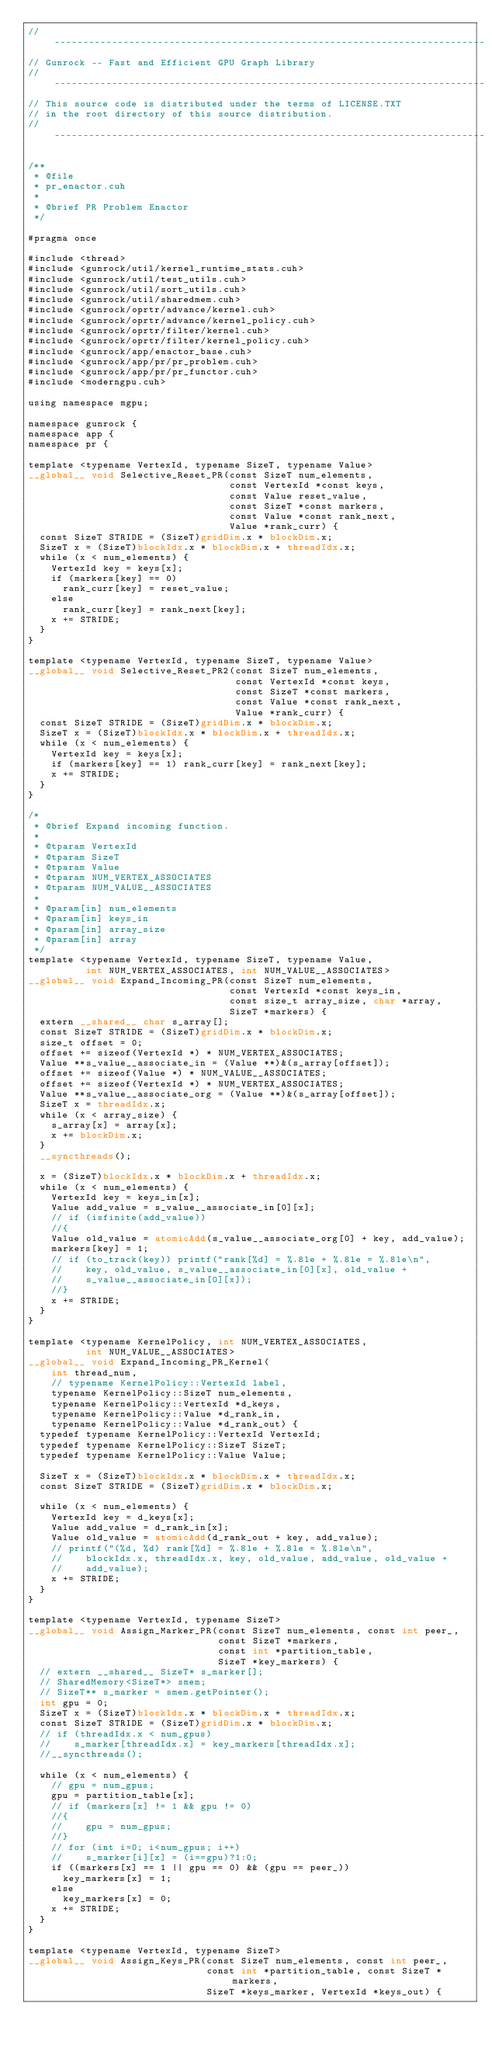<code> <loc_0><loc_0><loc_500><loc_500><_Cuda_>// ---------------------------------------------------------------------------
// Gunrock -- Fast and Efficient GPU Graph Library
// ---------------------------------------------------------------------------
// This source code is distributed under the terms of LICENSE.TXT
// in the root directory of this source distribution.
// ---------------------------------------------------------------------------

/**
 * @file
 * pr_enactor.cuh
 *
 * @brief PR Problem Enactor
 */

#pragma once

#include <thread>
#include <gunrock/util/kernel_runtime_stats.cuh>
#include <gunrock/util/test_utils.cuh>
#include <gunrock/util/sort_utils.cuh>
#include <gunrock/util/sharedmem.cuh>
#include <gunrock/oprtr/advance/kernel.cuh>
#include <gunrock/oprtr/advance/kernel_policy.cuh>
#include <gunrock/oprtr/filter/kernel.cuh>
#include <gunrock/oprtr/filter/kernel_policy.cuh>
#include <gunrock/app/enactor_base.cuh>
#include <gunrock/app/pr/pr_problem.cuh>
#include <gunrock/app/pr/pr_functor.cuh>
#include <moderngpu.cuh>

using namespace mgpu;

namespace gunrock {
namespace app {
namespace pr {

template <typename VertexId, typename SizeT, typename Value>
__global__ void Selective_Reset_PR(const SizeT num_elements,
                                   const VertexId *const keys,
                                   const Value reset_value,
                                   const SizeT *const markers,
                                   const Value *const rank_next,
                                   Value *rank_curr) {
  const SizeT STRIDE = (SizeT)gridDim.x * blockDim.x;
  SizeT x = (SizeT)blockIdx.x * blockDim.x + threadIdx.x;
  while (x < num_elements) {
    VertexId key = keys[x];
    if (markers[key] == 0)
      rank_curr[key] = reset_value;
    else
      rank_curr[key] = rank_next[key];
    x += STRIDE;
  }
}

template <typename VertexId, typename SizeT, typename Value>
__global__ void Selective_Reset_PR2(const SizeT num_elements,
                                    const VertexId *const keys,
                                    const SizeT *const markers,
                                    const Value *const rank_next,
                                    Value *rank_curr) {
  const SizeT STRIDE = (SizeT)gridDim.x * blockDim.x;
  SizeT x = (SizeT)blockIdx.x * blockDim.x + threadIdx.x;
  while (x < num_elements) {
    VertexId key = keys[x];
    if (markers[key] == 1) rank_curr[key] = rank_next[key];
    x += STRIDE;
  }
}

/*
 * @brief Expand incoming function.
 *
 * @tparam VertexId
 * @tparam SizeT
 * @tparam Value
 * @tparam NUM_VERTEX_ASSOCIATES
 * @tparam NUM_VALUE__ASSOCIATES
 *
 * @param[in] num_elements
 * @param[in] keys_in
 * @param[in] array_size
 * @param[in] array
 */
template <typename VertexId, typename SizeT, typename Value,
          int NUM_VERTEX_ASSOCIATES, int NUM_VALUE__ASSOCIATES>
__global__ void Expand_Incoming_PR(const SizeT num_elements,
                                   const VertexId *const keys_in,
                                   const size_t array_size, char *array,
                                   SizeT *markers) {
  extern __shared__ char s_array[];
  const SizeT STRIDE = (SizeT)gridDim.x * blockDim.x;
  size_t offset = 0;
  offset += sizeof(VertexId *) * NUM_VERTEX_ASSOCIATES;
  Value **s_value__associate_in = (Value **)&(s_array[offset]);
  offset += sizeof(Value *) * NUM_VALUE__ASSOCIATES;
  offset += sizeof(VertexId *) * NUM_VERTEX_ASSOCIATES;
  Value **s_value__associate_org = (Value **)&(s_array[offset]);
  SizeT x = threadIdx.x;
  while (x < array_size) {
    s_array[x] = array[x];
    x += blockDim.x;
  }
  __syncthreads();

  x = (SizeT)blockIdx.x * blockDim.x + threadIdx.x;
  while (x < num_elements) {
    VertexId key = keys_in[x];
    Value add_value = s_value__associate_in[0][x];
    // if (isfinite(add_value))
    //{
    Value old_value = atomicAdd(s_value__associate_org[0] + key, add_value);
    markers[key] = 1;
    // if (to_track(key)) printf("rank[%d] = %.8le + %.8le = %.8le\n",
    //    key, old_value, s_value__associate_in[0][x], old_value +
    //    s_value__associate_in[0][x]);
    //}
    x += STRIDE;
  }
}

template <typename KernelPolicy, int NUM_VERTEX_ASSOCIATES,
          int NUM_VALUE__ASSOCIATES>
__global__ void Expand_Incoming_PR_Kernel(
    int thread_num,
    // typename KernelPolicy::VertexId label,
    typename KernelPolicy::SizeT num_elements,
    typename KernelPolicy::VertexId *d_keys,
    typename KernelPolicy::Value *d_rank_in,
    typename KernelPolicy::Value *d_rank_out) {
  typedef typename KernelPolicy::VertexId VertexId;
  typedef typename KernelPolicy::SizeT SizeT;
  typedef typename KernelPolicy::Value Value;

  SizeT x = (SizeT)blockIdx.x * blockDim.x + threadIdx.x;
  const SizeT STRIDE = (SizeT)gridDim.x * blockDim.x;

  while (x < num_elements) {
    VertexId key = d_keys[x];
    Value add_value = d_rank_in[x];
    Value old_value = atomicAdd(d_rank_out + key, add_value);
    // printf("(%d, %d) rank[%d] = %.8le + %.8le = %.8le\n",
    //    blockIdx.x, threadIdx.x, key, old_value, add_value, old_value +
    //    add_value);
    x += STRIDE;
  }
}

template <typename VertexId, typename SizeT>
__global__ void Assign_Marker_PR(const SizeT num_elements, const int peer_,
                                 const SizeT *markers,
                                 const int *partition_table,
                                 SizeT *key_markers) {
  // extern __shared__ SizeT* s_marker[];
  // SharedMemory<SizeT*> smem;
  // SizeT** s_marker = smem.getPointer();
  int gpu = 0;
  SizeT x = (SizeT)blockIdx.x * blockDim.x + threadIdx.x;
  const SizeT STRIDE = (SizeT)gridDim.x * blockDim.x;
  // if (threadIdx.x < num_gpus)
  //    s_marker[threadIdx.x] = key_markers[threadIdx.x];
  //__syncthreads();

  while (x < num_elements) {
    // gpu = num_gpus;
    gpu = partition_table[x];
    // if (markers[x] != 1 && gpu != 0)
    //{
    //    gpu = num_gpus;
    //}
    // for (int i=0; i<num_gpus; i++)
    //    s_marker[i][x] = (i==gpu)?1:0;
    if ((markers[x] == 1 || gpu == 0) && (gpu == peer_))
      key_markers[x] = 1;
    else
      key_markers[x] = 0;
    x += STRIDE;
  }
}

template <typename VertexId, typename SizeT>
__global__ void Assign_Keys_PR(const SizeT num_elements, const int peer_,
                               const int *partition_table, const SizeT *markers,
                               SizeT *keys_marker, VertexId *keys_out) {</code> 